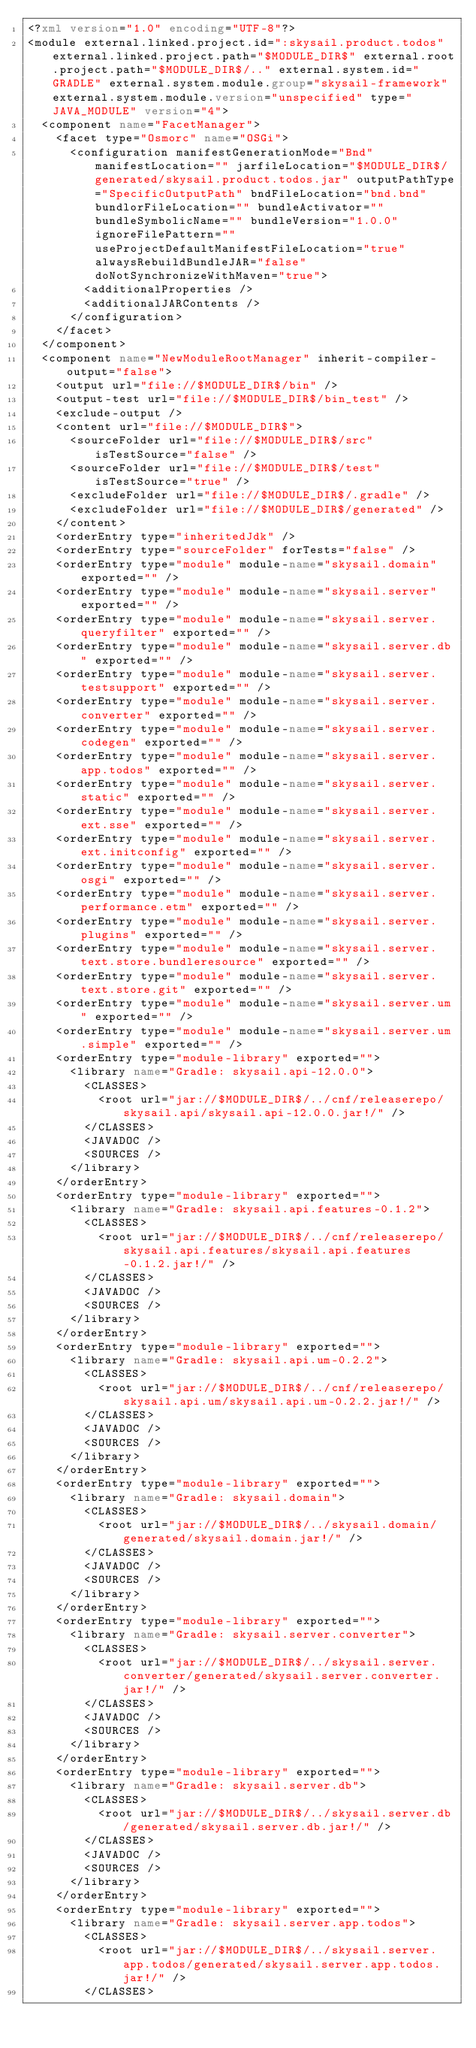<code> <loc_0><loc_0><loc_500><loc_500><_XML_><?xml version="1.0" encoding="UTF-8"?>
<module external.linked.project.id=":skysail.product.todos" external.linked.project.path="$MODULE_DIR$" external.root.project.path="$MODULE_DIR$/.." external.system.id="GRADLE" external.system.module.group="skysail-framework" external.system.module.version="unspecified" type="JAVA_MODULE" version="4">
  <component name="FacetManager">
    <facet type="Osmorc" name="OSGi">
      <configuration manifestGenerationMode="Bnd" manifestLocation="" jarfileLocation="$MODULE_DIR$/generated/skysail.product.todos.jar" outputPathType="SpecificOutputPath" bndFileLocation="bnd.bnd" bundlorFileLocation="" bundleActivator="" bundleSymbolicName="" bundleVersion="1.0.0" ignoreFilePattern="" useProjectDefaultManifestFileLocation="true" alwaysRebuildBundleJAR="false" doNotSynchronizeWithMaven="true">
        <additionalProperties />
        <additionalJARContents />
      </configuration>
    </facet>
  </component>
  <component name="NewModuleRootManager" inherit-compiler-output="false">
    <output url="file://$MODULE_DIR$/bin" />
    <output-test url="file://$MODULE_DIR$/bin_test" />
    <exclude-output />
    <content url="file://$MODULE_DIR$">
      <sourceFolder url="file://$MODULE_DIR$/src" isTestSource="false" />
      <sourceFolder url="file://$MODULE_DIR$/test" isTestSource="true" />
      <excludeFolder url="file://$MODULE_DIR$/.gradle" />
      <excludeFolder url="file://$MODULE_DIR$/generated" />
    </content>
    <orderEntry type="inheritedJdk" />
    <orderEntry type="sourceFolder" forTests="false" />
    <orderEntry type="module" module-name="skysail.domain" exported="" />
    <orderEntry type="module" module-name="skysail.server" exported="" />
    <orderEntry type="module" module-name="skysail.server.queryfilter" exported="" />
    <orderEntry type="module" module-name="skysail.server.db" exported="" />
    <orderEntry type="module" module-name="skysail.server.testsupport" exported="" />
    <orderEntry type="module" module-name="skysail.server.converter" exported="" />
    <orderEntry type="module" module-name="skysail.server.codegen" exported="" />
    <orderEntry type="module" module-name="skysail.server.app.todos" exported="" />
    <orderEntry type="module" module-name="skysail.server.static" exported="" />
    <orderEntry type="module" module-name="skysail.server.ext.sse" exported="" />
    <orderEntry type="module" module-name="skysail.server.ext.initconfig" exported="" />
    <orderEntry type="module" module-name="skysail.server.osgi" exported="" />
    <orderEntry type="module" module-name="skysail.server.performance.etm" exported="" />
    <orderEntry type="module" module-name="skysail.server.plugins" exported="" />
    <orderEntry type="module" module-name="skysail.server.text.store.bundleresource" exported="" />
    <orderEntry type="module" module-name="skysail.server.text.store.git" exported="" />
    <orderEntry type="module" module-name="skysail.server.um" exported="" />
    <orderEntry type="module" module-name="skysail.server.um.simple" exported="" />
    <orderEntry type="module-library" exported="">
      <library name="Gradle: skysail.api-12.0.0">
        <CLASSES>
          <root url="jar://$MODULE_DIR$/../cnf/releaserepo/skysail.api/skysail.api-12.0.0.jar!/" />
        </CLASSES>
        <JAVADOC />
        <SOURCES />
      </library>
    </orderEntry>
    <orderEntry type="module-library" exported="">
      <library name="Gradle: skysail.api.features-0.1.2">
        <CLASSES>
          <root url="jar://$MODULE_DIR$/../cnf/releaserepo/skysail.api.features/skysail.api.features-0.1.2.jar!/" />
        </CLASSES>
        <JAVADOC />
        <SOURCES />
      </library>
    </orderEntry>
    <orderEntry type="module-library" exported="">
      <library name="Gradle: skysail.api.um-0.2.2">
        <CLASSES>
          <root url="jar://$MODULE_DIR$/../cnf/releaserepo/skysail.api.um/skysail.api.um-0.2.2.jar!/" />
        </CLASSES>
        <JAVADOC />
        <SOURCES />
      </library>
    </orderEntry>
    <orderEntry type="module-library" exported="">
      <library name="Gradle: skysail.domain">
        <CLASSES>
          <root url="jar://$MODULE_DIR$/../skysail.domain/generated/skysail.domain.jar!/" />
        </CLASSES>
        <JAVADOC />
        <SOURCES />
      </library>
    </orderEntry>
    <orderEntry type="module-library" exported="">
      <library name="Gradle: skysail.server.converter">
        <CLASSES>
          <root url="jar://$MODULE_DIR$/../skysail.server.converter/generated/skysail.server.converter.jar!/" />
        </CLASSES>
        <JAVADOC />
        <SOURCES />
      </library>
    </orderEntry>
    <orderEntry type="module-library" exported="">
      <library name="Gradle: skysail.server.db">
        <CLASSES>
          <root url="jar://$MODULE_DIR$/../skysail.server.db/generated/skysail.server.db.jar!/" />
        </CLASSES>
        <JAVADOC />
        <SOURCES />
      </library>
    </orderEntry>
    <orderEntry type="module-library" exported="">
      <library name="Gradle: skysail.server.app.todos">
        <CLASSES>
          <root url="jar://$MODULE_DIR$/../skysail.server.app.todos/generated/skysail.server.app.todos.jar!/" />
        </CLASSES></code> 